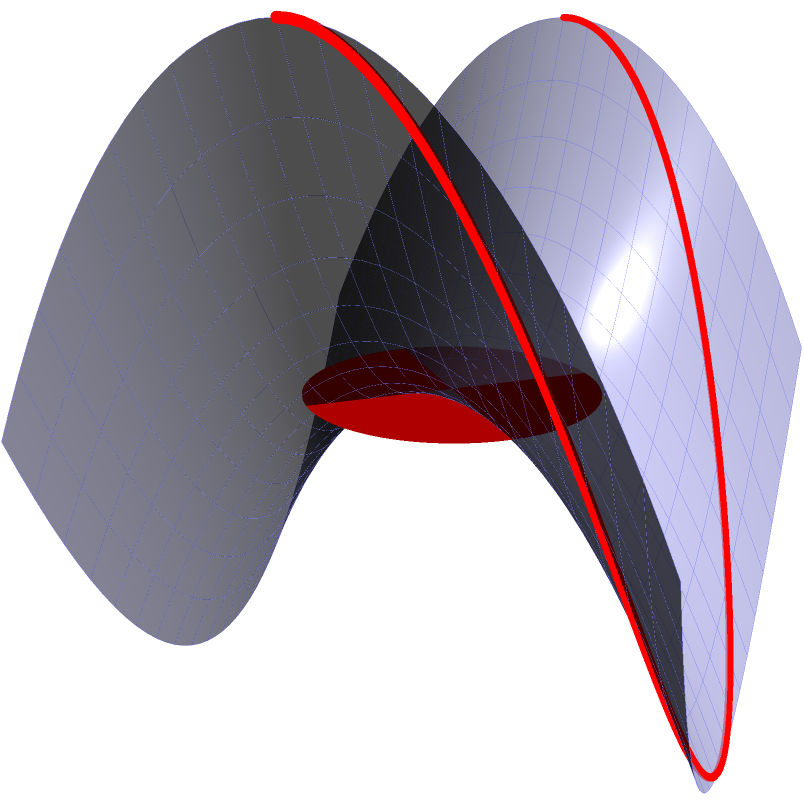On this saddle-shaped surface, which resembles the emotional rollercoaster of waiting for Baby Queen's new album, what is the shape of the shortest path (geodesic) between two points on opposite sides of the saddle? Let's break this down step-by-step:

1) The surface shown is a hyperbolic paraboloid, often called a "saddle surface" due to its shape. It's described by the equation $z = x^2 - y^2$.

2) In Euclidean geometry, the shortest path between two points is always a straight line. However, on curved surfaces like this one, the shortest path (called a geodesic) can be curved.

3) For this particular surface:
   - The red curve on the surface represents the geodesic.
   - The red circle at the bottom represents the projection of this path onto the xy-plane.

4) The geodesic on this surface is not a straight line, but rather a curved path that follows the contours of the surface.

5) The projection of this geodesic onto the xy-plane is actually a straight line. This is a special property of hyperbolic paraboloids.

6) The shape of the geodesic on the surface itself appears to be an S-shaped curve. It starts high on one side of the saddle, dips down as it crosses the center, and then rises up again on the other side.

7) This S-shape allows the path to minimize its length by taking advantage of the surface's curvature, much like how Baby Queen's lyrics navigate the ups and downs of emotions.
Answer: S-shaped curve 